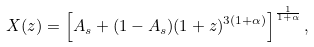<formula> <loc_0><loc_0><loc_500><loc_500>X ( z ) = \left [ A _ { s } + ( 1 - A _ { s } ) ( 1 + z ) ^ { 3 ( 1 + \alpha ) } \right ] ^ { \frac { 1 } { 1 + \alpha } } ,</formula> 